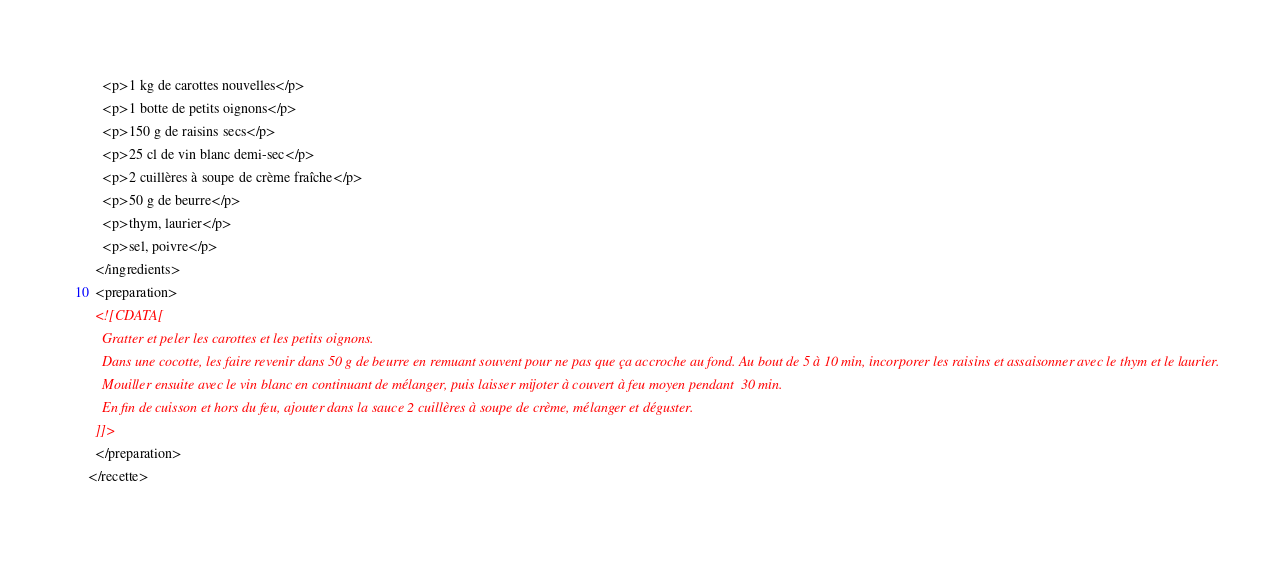Convert code to text. <code><loc_0><loc_0><loc_500><loc_500><_XML_>    <p>1 kg de carottes nouvelles</p>
    <p>1 botte de petits oignons</p>
    <p>150 g de raisins secs</p>
    <p>25 cl de vin blanc demi-sec</p>
    <p>2 cuillères à soupe de crème fraîche</p>
    <p>50 g de beurre</p>
    <p>thym, laurier</p>
    <p>sel, poivre</p>
  </ingredients>
  <preparation>
  <![CDATA[
    Gratter et peler les carottes et les petits oignons.
    Dans une cocotte, les faire revenir dans 50 g de beurre en remuant souvent pour ne pas que ça accroche au fond. Au bout de 5 à 10 min, incorporer les raisins et assaisonner avec le thym et le laurier.
    Mouiller ensuite avec le vin blanc en continuant de mélanger, puis laisser mijoter à couvert à feu moyen pendant  30 min.
    En fin de cuisson et hors du feu, ajouter dans la sauce 2 cuillères à soupe de crème, mélanger et déguster.
  ]]>
  </preparation>
</recette>
</code> 